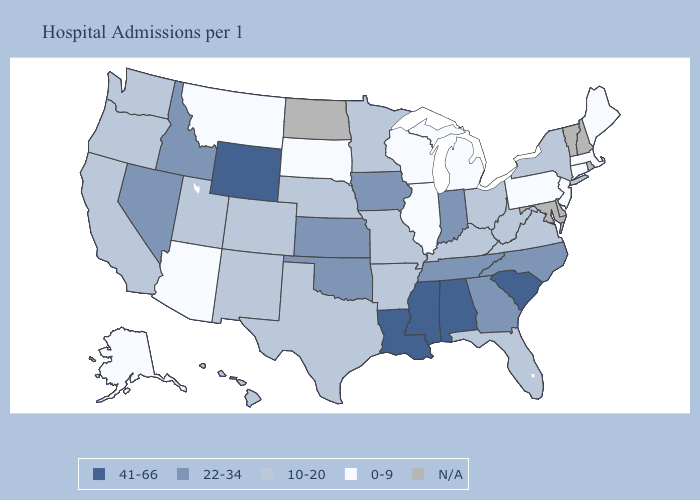What is the value of Missouri?
Give a very brief answer. 10-20. Does Maine have the highest value in the Northeast?
Give a very brief answer. No. What is the lowest value in the USA?
Keep it brief. 0-9. What is the value of Montana?
Short answer required. 0-9. What is the highest value in the USA?
Be succinct. 41-66. Among the states that border Arkansas , which have the lowest value?
Be succinct. Missouri, Texas. Among the states that border Illinois , which have the highest value?
Answer briefly. Indiana, Iowa. Name the states that have a value in the range 41-66?
Keep it brief. Alabama, Louisiana, Mississippi, South Carolina, Wyoming. Does Illinois have the lowest value in the USA?
Write a very short answer. Yes. Name the states that have a value in the range N/A?
Short answer required. Delaware, Maryland, New Hampshire, North Dakota, Rhode Island, Vermont. Among the states that border Montana , does South Dakota have the highest value?
Write a very short answer. No. How many symbols are there in the legend?
Give a very brief answer. 5. Which states have the lowest value in the West?
Answer briefly. Alaska, Arizona, Montana. What is the lowest value in the MidWest?
Answer briefly. 0-9. Does Louisiana have the highest value in the USA?
Quick response, please. Yes. 